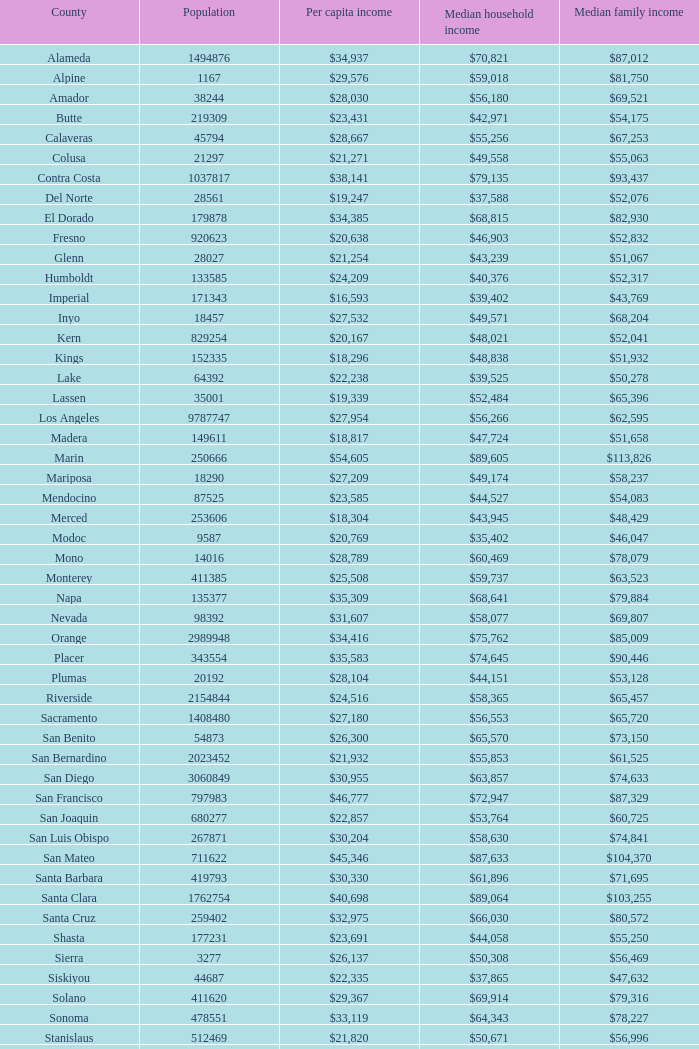What is the median household income of butte? $42,971. 